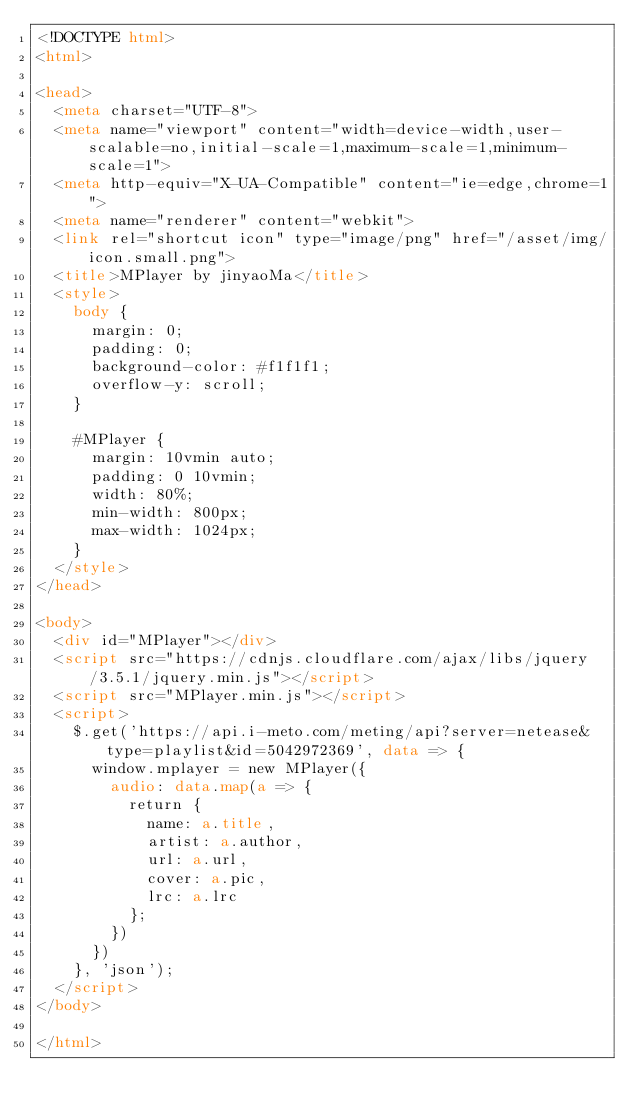Convert code to text. <code><loc_0><loc_0><loc_500><loc_500><_HTML_><!DOCTYPE html>
<html>

<head>
  <meta charset="UTF-8">
  <meta name="viewport" content="width=device-width,user-scalable=no,initial-scale=1,maximum-scale=1,minimum-scale=1">
  <meta http-equiv="X-UA-Compatible" content="ie=edge,chrome=1">
  <meta name="renderer" content="webkit">
  <link rel="shortcut icon" type="image/png" href="/asset/img/icon.small.png">
  <title>MPlayer by jinyaoMa</title>
  <style>
    body {
      margin: 0;
      padding: 0;
      background-color: #f1f1f1;
      overflow-y: scroll;
    }

    #MPlayer {
      margin: 10vmin auto;
      padding: 0 10vmin;
      width: 80%;
      min-width: 800px;
      max-width: 1024px;
    }
  </style>
</head>

<body>
  <div id="MPlayer"></div>
  <script src="https://cdnjs.cloudflare.com/ajax/libs/jquery/3.5.1/jquery.min.js"></script>
  <script src="MPlayer.min.js"></script>
  <script>
    $.get('https://api.i-meto.com/meting/api?server=netease&type=playlist&id=5042972369', data => {
      window.mplayer = new MPlayer({
        audio: data.map(a => {
          return {
            name: a.title,
            artist: a.author,
            url: a.url,
            cover: a.pic,
            lrc: a.lrc
          };
        })
      })
    }, 'json');
  </script>
</body>

</html>
</code> 